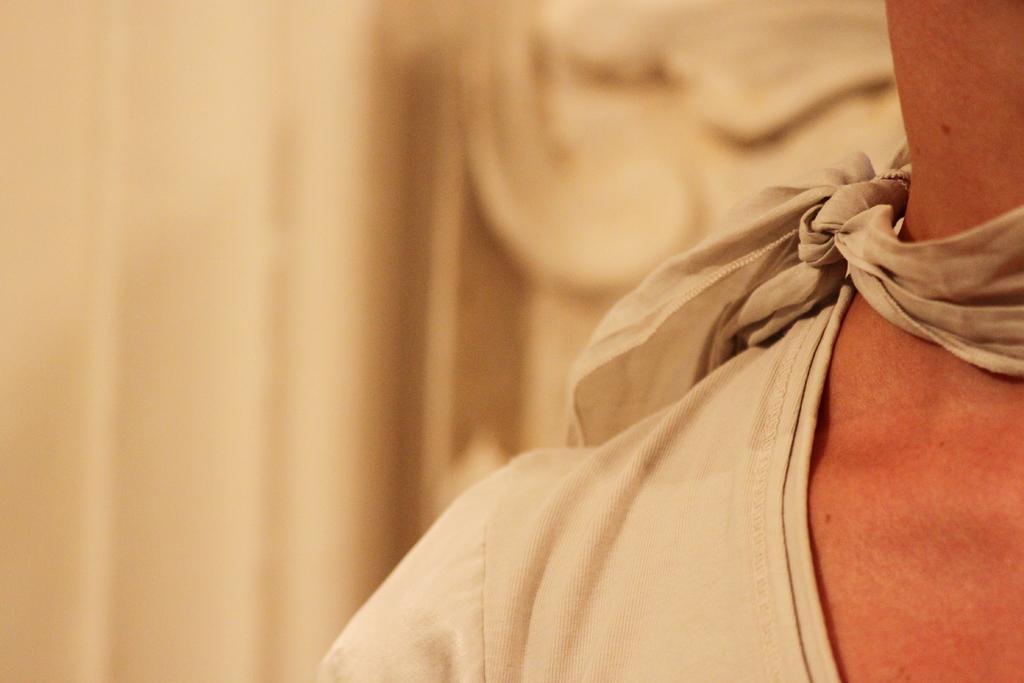Describe this image in one or two sentences. On the right side of the picture we can see person neck, shoulder and clothes. In the background of the image it is blurry. 